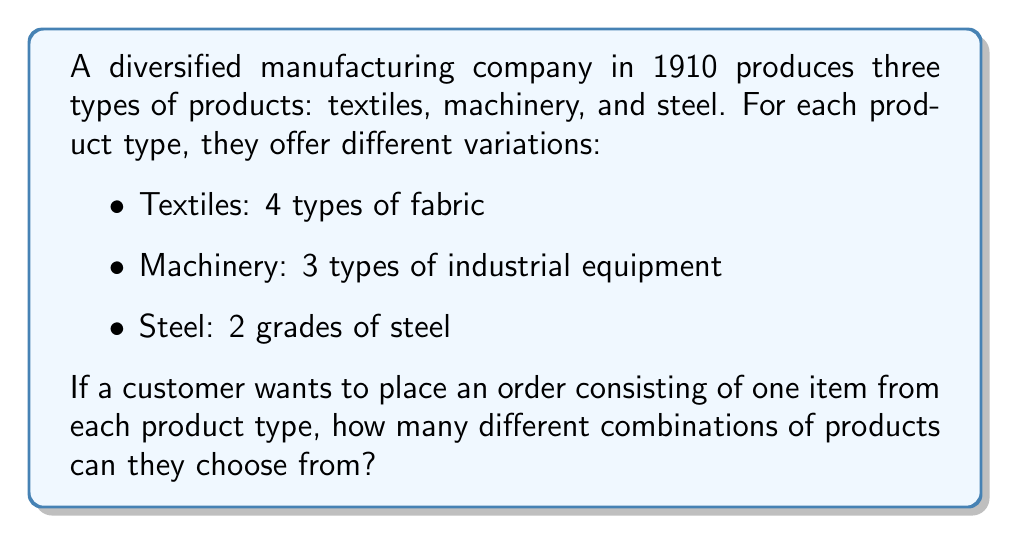Give your solution to this math problem. To solve this problem, we'll use the multiplication principle of counting. This principle states that if we have a series of independent choices, the total number of possible outcomes is the product of the number of possibilities for each choice.

Let's break it down step-by-step:

1. For textiles, there are 4 choices.
2. For machinery, there are 3 choices.
3. For steel, there are 2 choices.

Since the customer is selecting one item from each product type, and the choices are independent of each other, we multiply these numbers together:

$$ \text{Total combinations} = 4 \times 3 \times 2 $$

$$ = 24 $$

This means that there are 24 different possible combinations of products that a customer can order, choosing one item from each of the three product types.
Answer: 24 combinations 